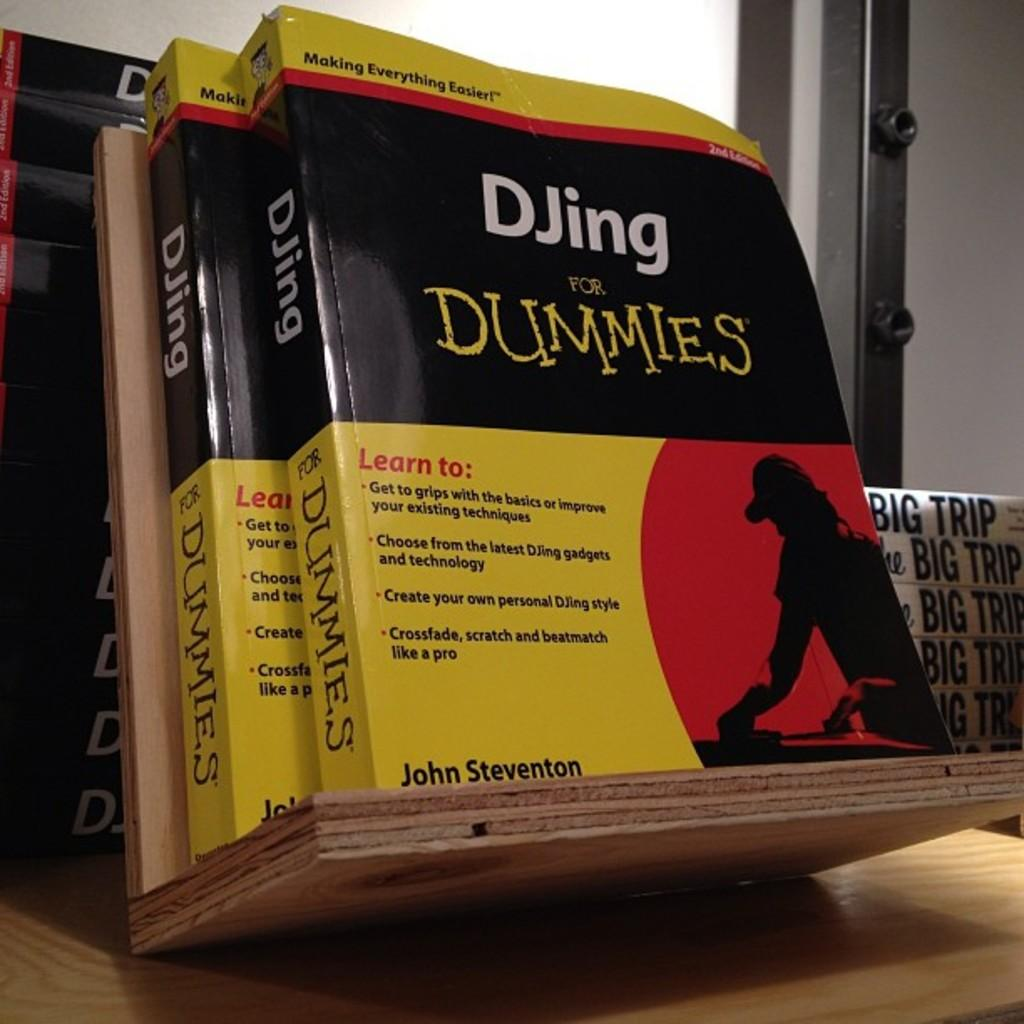<image>
Give a short and clear explanation of the subsequent image. Two DJing for DUMMIES books are on a wood shelf. 